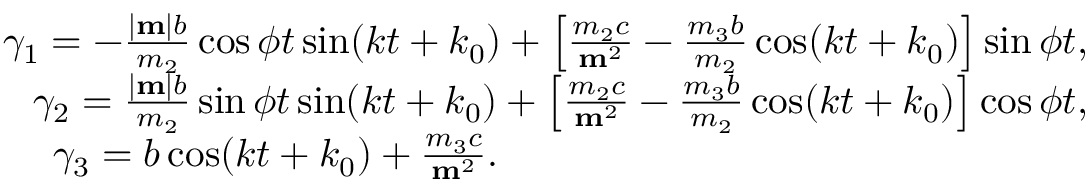<formula> <loc_0><loc_0><loc_500><loc_500>\begin{array} { r } { \gamma _ { 1 } = - \frac { | { m } | b } { m _ { 2 } } \cos \phi t \sin ( k t + k _ { 0 } ) + \left [ \frac { m _ { 2 } c } { { m } ^ { 2 } } - \frac { m _ { 3 } b } { m _ { 2 } } \cos ( k t + k _ { 0 } ) \right ] \sin \phi t , } \\ { \gamma _ { 2 } = \frac { | { m } | b } { m _ { 2 } } \sin \phi t \sin ( k t + k _ { 0 } ) + \left [ \frac { m _ { 2 } c } { { m } ^ { 2 } } - \frac { m _ { 3 } b } { m _ { 2 } } \cos ( k t + k _ { 0 } ) \right ] \cos \phi t , } \\ { \gamma _ { 3 } = b \cos ( k t + k _ { 0 } ) + \frac { m _ { 3 } c } { { m } ^ { 2 } } . \quad } \end{array}</formula> 